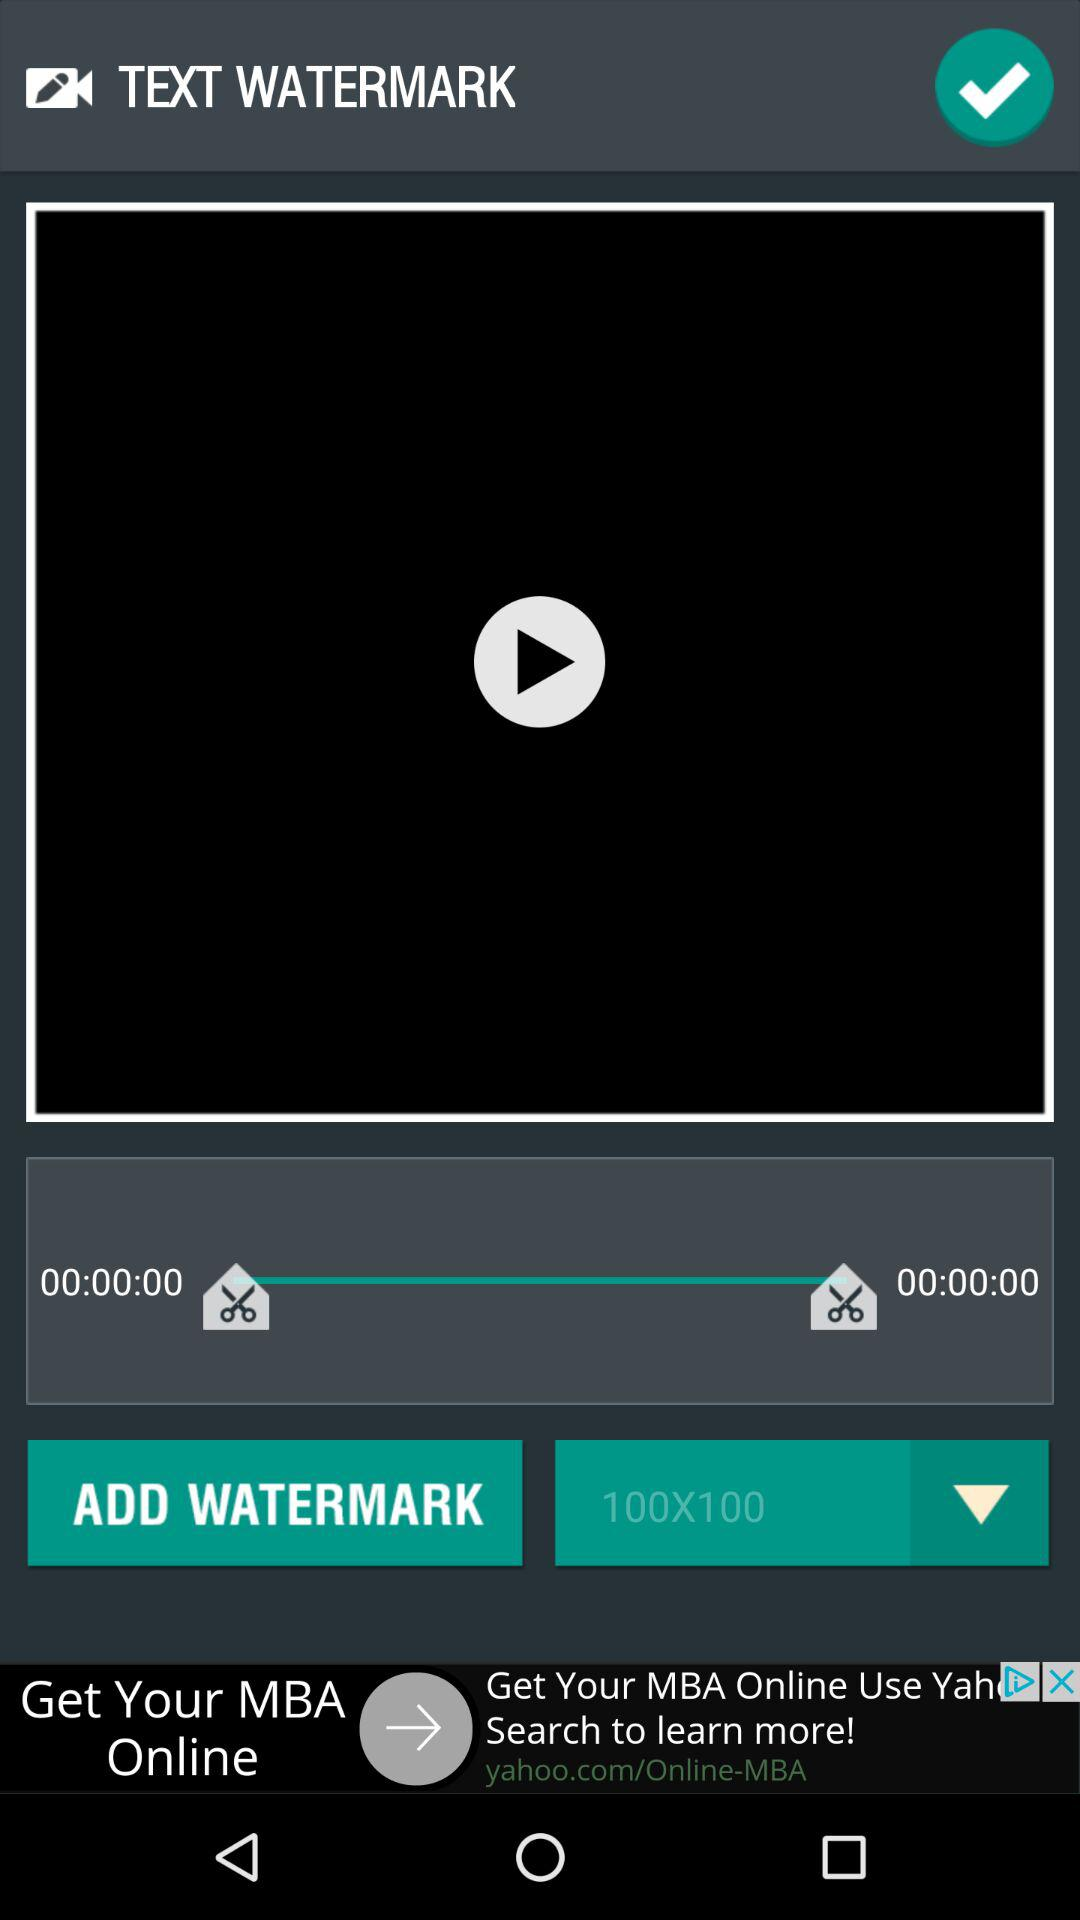How many text elements are there that are not watermarks?
Answer the question using a single word or phrase. 2 